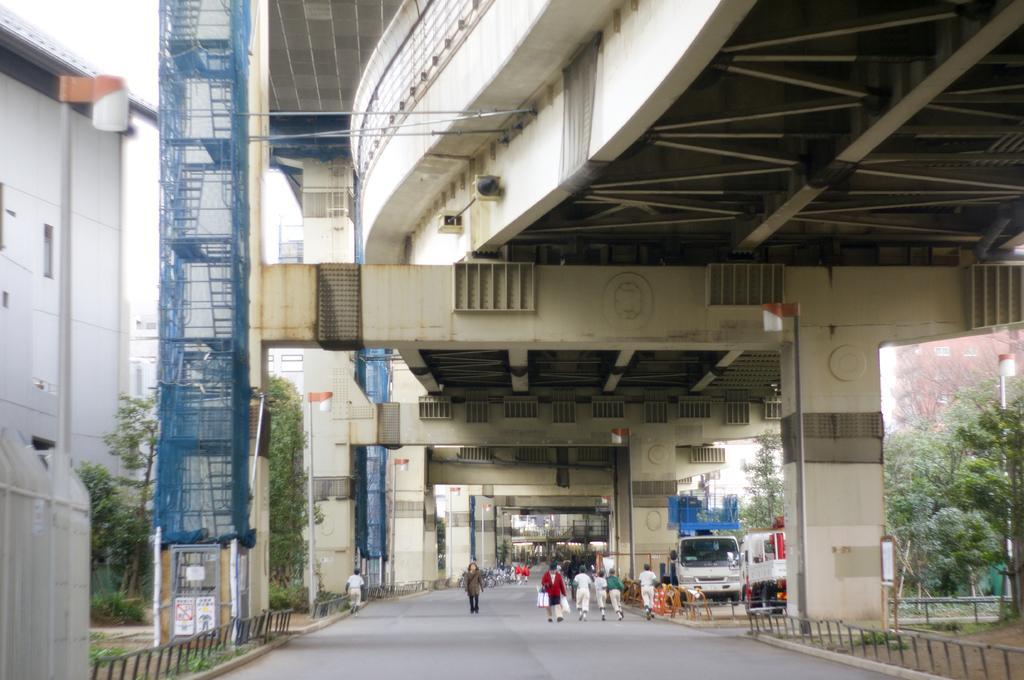Describe this image in one or two sentences. In this image we can see some persons walking through the road, there are some vehicles parked under the bridge, top of the image there is bridge and there are some trees on left and right side of the image. 